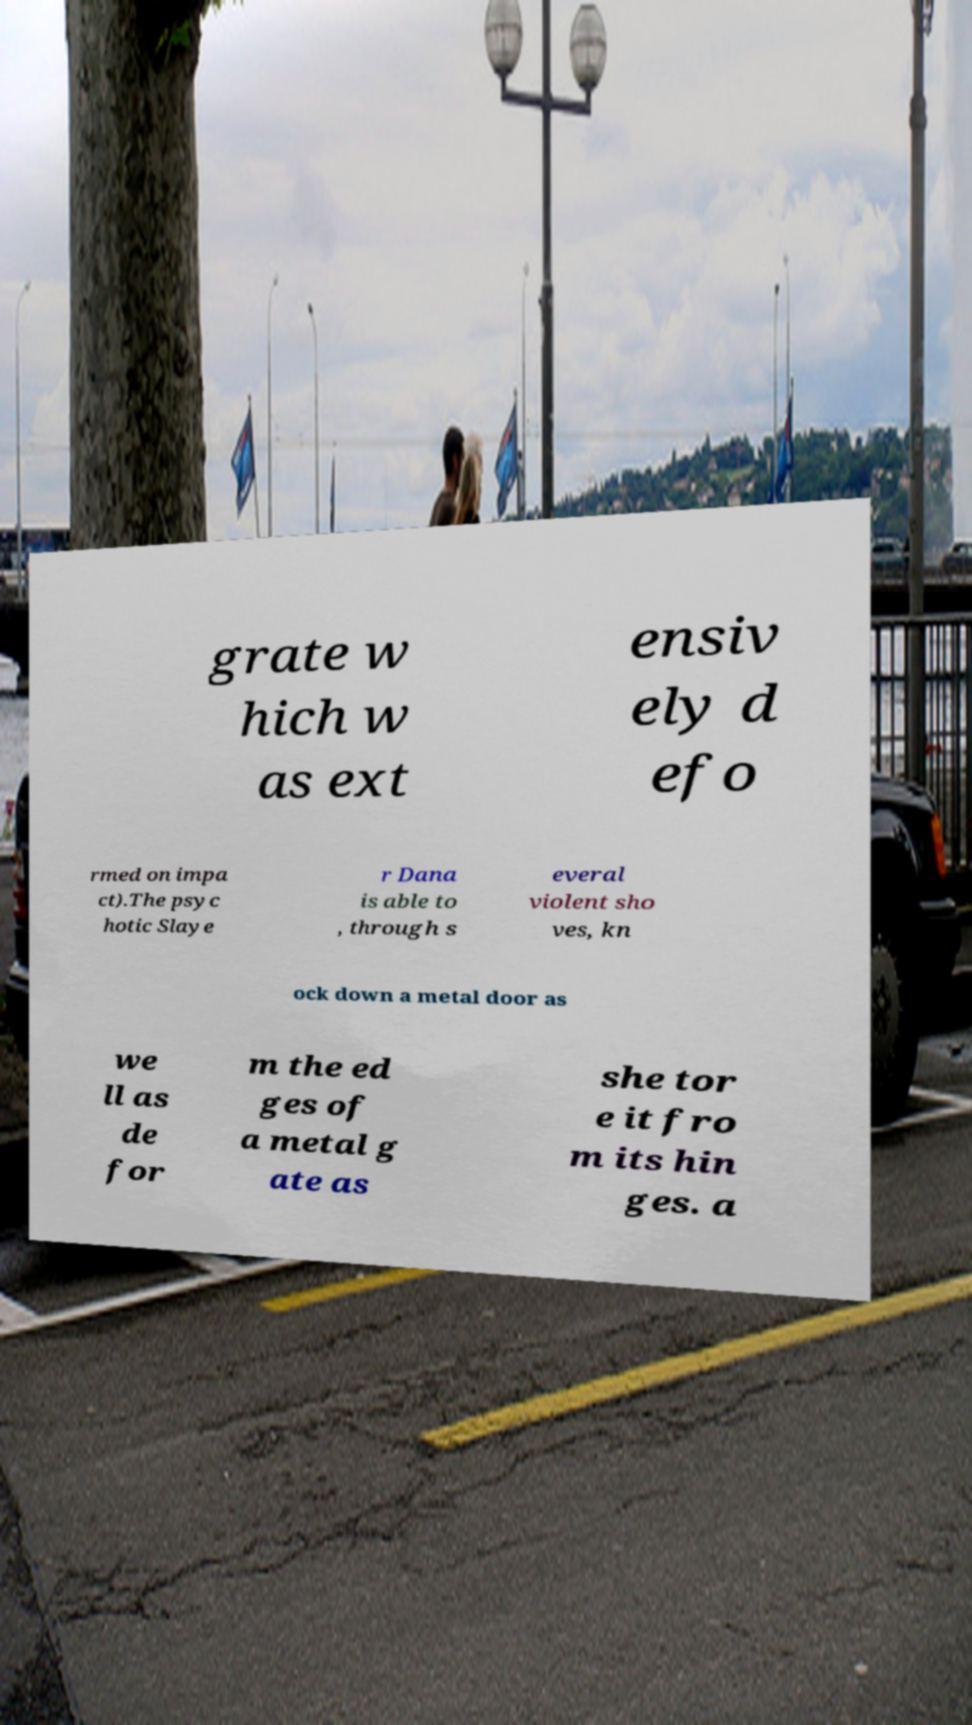What messages or text are displayed in this image? I need them in a readable, typed format. grate w hich w as ext ensiv ely d efo rmed on impa ct).The psyc hotic Slaye r Dana is able to , through s everal violent sho ves, kn ock down a metal door as we ll as de for m the ed ges of a metal g ate as she tor e it fro m its hin ges. a 